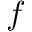<formula> <loc_0><loc_0><loc_500><loc_500>f</formula> 